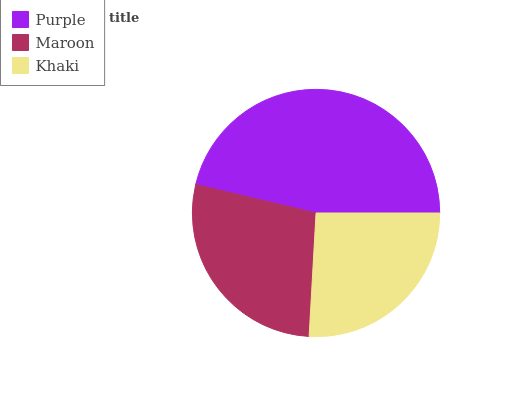Is Khaki the minimum?
Answer yes or no. Yes. Is Purple the maximum?
Answer yes or no. Yes. Is Maroon the minimum?
Answer yes or no. No. Is Maroon the maximum?
Answer yes or no. No. Is Purple greater than Maroon?
Answer yes or no. Yes. Is Maroon less than Purple?
Answer yes or no. Yes. Is Maroon greater than Purple?
Answer yes or no. No. Is Purple less than Maroon?
Answer yes or no. No. Is Maroon the high median?
Answer yes or no. Yes. Is Maroon the low median?
Answer yes or no. Yes. Is Khaki the high median?
Answer yes or no. No. Is Khaki the low median?
Answer yes or no. No. 